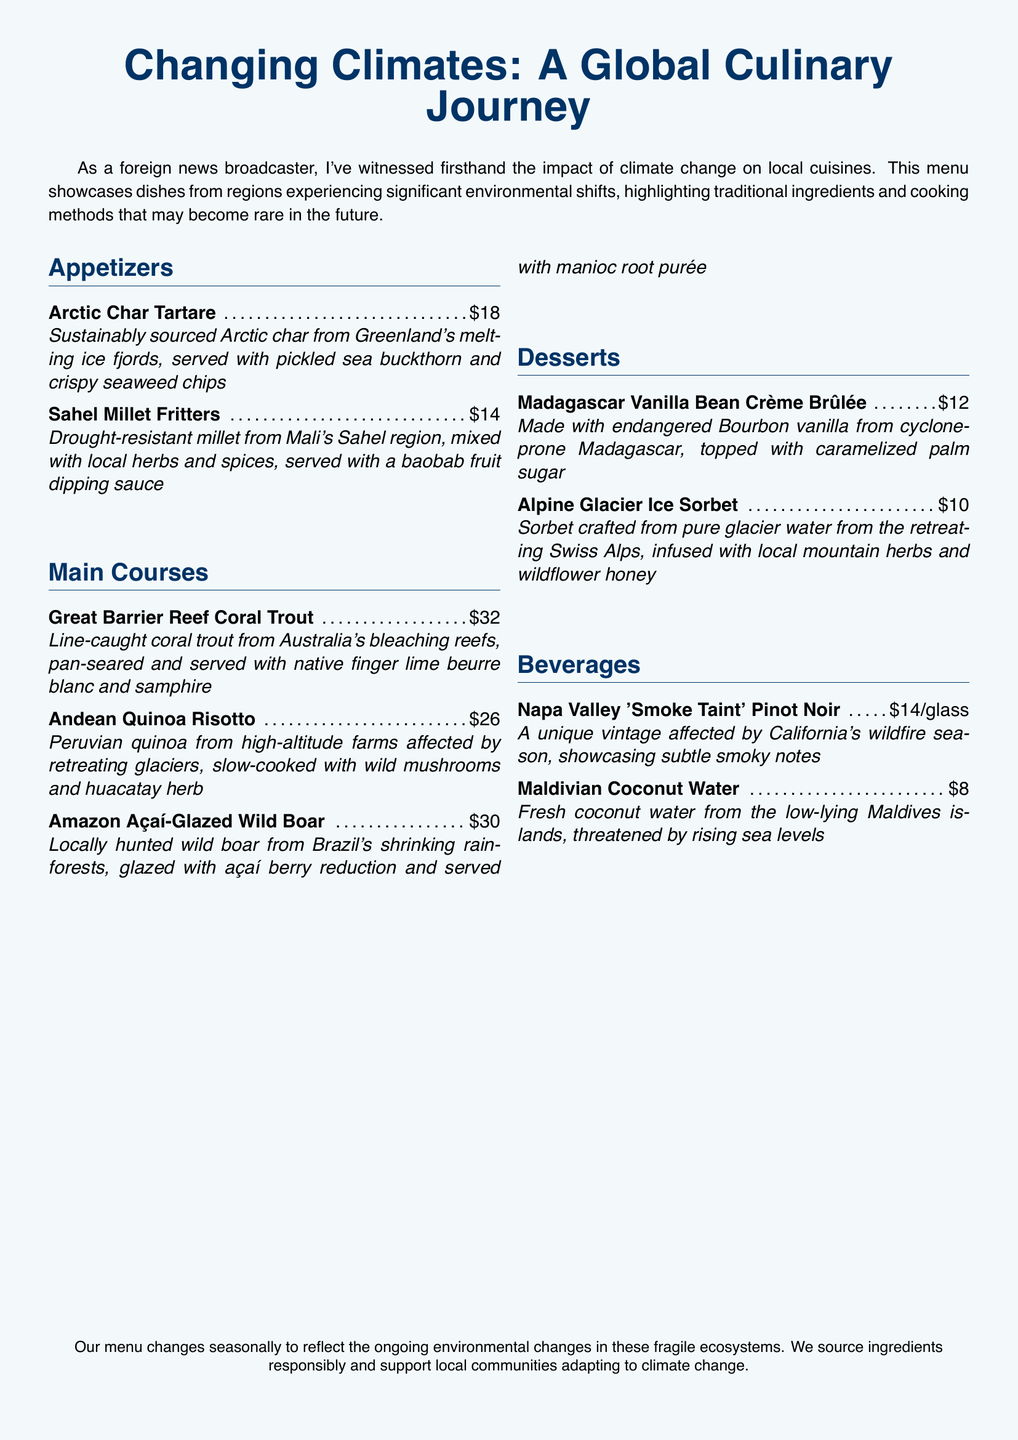what is the title of the menu? The title of the menu is prominently displayed at the top of the document.
Answer: Changing Climates: A Global Culinary Journey how much is the Arctic Char Tartare? The price for the Arctic Char Tartare is listed under the Appetizers section.
Answer: $18 which dessert uses endangered vanilla? The dessert that features endangered vanilla is noted in its description.
Answer: Madagascar Vanilla Bean Crème Brûlée what region is the origin of the Andean Quinoa Risotto? The origin of the quinoa used in this dish is detailed within the menu description.
Answer: Peru how many beverages are listed on the menu? The total number of beverages can be counted from the Beverages section.
Answer: 2 what is the main ingredient in the Sahel Millet Fritters? The main ingredient is identified in the dish's description.
Answer: Millet which dish is associated with the Great Barrier Reef? The dish associated with the Great Barrier Reef is explicitly mentioned in the Main Courses section.
Answer: Great Barrier Reef Coral Trout what environmental factor affects the Napa Valley Pinot Noir? The environmental factor affecting this wine is provided in its description.
Answer: Wildfire season how does the menu address environmental changes? The menu concludes with a note on how it adapts to environmental changes.
Answer: Seasonal updates 